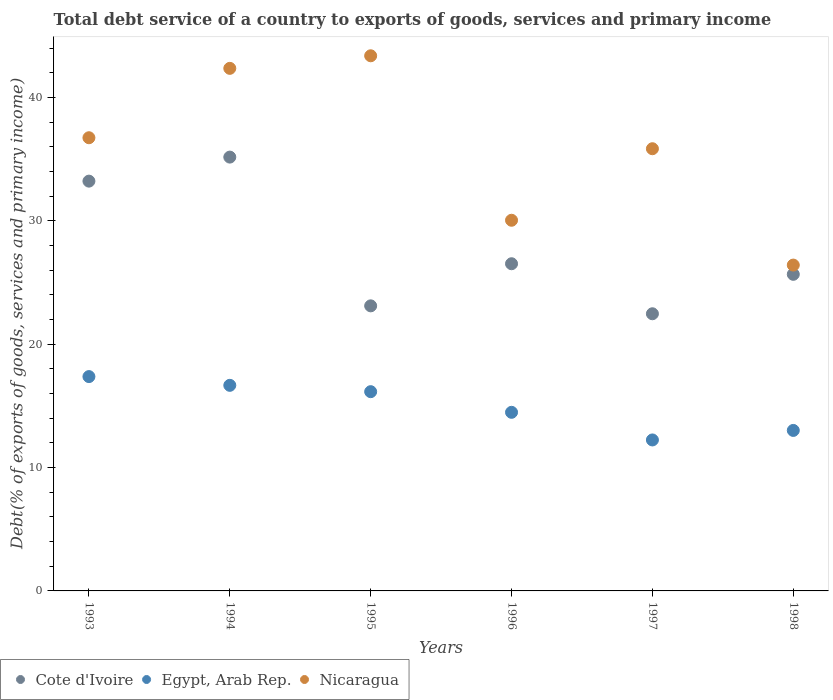How many different coloured dotlines are there?
Provide a succinct answer. 3. What is the total debt service in Nicaragua in 1997?
Your answer should be very brief. 35.85. Across all years, what is the maximum total debt service in Egypt, Arab Rep.?
Offer a very short reply. 17.38. Across all years, what is the minimum total debt service in Egypt, Arab Rep.?
Offer a terse response. 12.24. In which year was the total debt service in Nicaragua minimum?
Make the answer very short. 1998. What is the total total debt service in Nicaragua in the graph?
Make the answer very short. 214.82. What is the difference between the total debt service in Egypt, Arab Rep. in 1993 and that in 1998?
Give a very brief answer. 4.36. What is the difference between the total debt service in Nicaragua in 1998 and the total debt service in Egypt, Arab Rep. in 1996?
Ensure brevity in your answer.  11.94. What is the average total debt service in Cote d'Ivoire per year?
Keep it short and to the point. 27.7. In the year 1996, what is the difference between the total debt service in Cote d'Ivoire and total debt service in Nicaragua?
Offer a very short reply. -3.53. What is the ratio of the total debt service in Cote d'Ivoire in 1994 to that in 1996?
Offer a very short reply. 1.33. What is the difference between the highest and the second highest total debt service in Nicaragua?
Make the answer very short. 1.02. What is the difference between the highest and the lowest total debt service in Cote d'Ivoire?
Give a very brief answer. 12.7. Does the total debt service in Egypt, Arab Rep. monotonically increase over the years?
Your answer should be compact. No. Is the total debt service in Egypt, Arab Rep. strictly less than the total debt service in Cote d'Ivoire over the years?
Offer a very short reply. Yes. How many dotlines are there?
Your answer should be very brief. 3. How many years are there in the graph?
Provide a short and direct response. 6. Are the values on the major ticks of Y-axis written in scientific E-notation?
Your answer should be very brief. No. Where does the legend appear in the graph?
Offer a terse response. Bottom left. How are the legend labels stacked?
Ensure brevity in your answer.  Horizontal. What is the title of the graph?
Your answer should be very brief. Total debt service of a country to exports of goods, services and primary income. Does "Caribbean small states" appear as one of the legend labels in the graph?
Give a very brief answer. No. What is the label or title of the Y-axis?
Give a very brief answer. Debt(% of exports of goods, services and primary income). What is the Debt(% of exports of goods, services and primary income) of Cote d'Ivoire in 1993?
Offer a terse response. 33.22. What is the Debt(% of exports of goods, services and primary income) in Egypt, Arab Rep. in 1993?
Ensure brevity in your answer.  17.38. What is the Debt(% of exports of goods, services and primary income) in Nicaragua in 1993?
Offer a terse response. 36.74. What is the Debt(% of exports of goods, services and primary income) of Cote d'Ivoire in 1994?
Offer a very short reply. 35.17. What is the Debt(% of exports of goods, services and primary income) of Egypt, Arab Rep. in 1994?
Give a very brief answer. 16.67. What is the Debt(% of exports of goods, services and primary income) of Nicaragua in 1994?
Your answer should be very brief. 42.37. What is the Debt(% of exports of goods, services and primary income) in Cote d'Ivoire in 1995?
Your answer should be compact. 23.11. What is the Debt(% of exports of goods, services and primary income) of Egypt, Arab Rep. in 1995?
Give a very brief answer. 16.15. What is the Debt(% of exports of goods, services and primary income) of Nicaragua in 1995?
Offer a very short reply. 43.39. What is the Debt(% of exports of goods, services and primary income) in Cote d'Ivoire in 1996?
Offer a terse response. 26.53. What is the Debt(% of exports of goods, services and primary income) in Egypt, Arab Rep. in 1996?
Offer a very short reply. 14.48. What is the Debt(% of exports of goods, services and primary income) of Nicaragua in 1996?
Ensure brevity in your answer.  30.05. What is the Debt(% of exports of goods, services and primary income) of Cote d'Ivoire in 1997?
Keep it short and to the point. 22.47. What is the Debt(% of exports of goods, services and primary income) in Egypt, Arab Rep. in 1997?
Make the answer very short. 12.24. What is the Debt(% of exports of goods, services and primary income) of Nicaragua in 1997?
Provide a short and direct response. 35.85. What is the Debt(% of exports of goods, services and primary income) of Cote d'Ivoire in 1998?
Ensure brevity in your answer.  25.67. What is the Debt(% of exports of goods, services and primary income) in Egypt, Arab Rep. in 1998?
Keep it short and to the point. 13.01. What is the Debt(% of exports of goods, services and primary income) of Nicaragua in 1998?
Offer a terse response. 26.42. Across all years, what is the maximum Debt(% of exports of goods, services and primary income) of Cote d'Ivoire?
Provide a short and direct response. 35.17. Across all years, what is the maximum Debt(% of exports of goods, services and primary income) in Egypt, Arab Rep.?
Your response must be concise. 17.38. Across all years, what is the maximum Debt(% of exports of goods, services and primary income) in Nicaragua?
Your answer should be very brief. 43.39. Across all years, what is the minimum Debt(% of exports of goods, services and primary income) of Cote d'Ivoire?
Provide a short and direct response. 22.47. Across all years, what is the minimum Debt(% of exports of goods, services and primary income) in Egypt, Arab Rep.?
Keep it short and to the point. 12.24. Across all years, what is the minimum Debt(% of exports of goods, services and primary income) in Nicaragua?
Offer a very short reply. 26.42. What is the total Debt(% of exports of goods, services and primary income) of Cote d'Ivoire in the graph?
Keep it short and to the point. 166.17. What is the total Debt(% of exports of goods, services and primary income) of Egypt, Arab Rep. in the graph?
Offer a terse response. 89.93. What is the total Debt(% of exports of goods, services and primary income) in Nicaragua in the graph?
Offer a very short reply. 214.82. What is the difference between the Debt(% of exports of goods, services and primary income) of Cote d'Ivoire in 1993 and that in 1994?
Offer a very short reply. -1.95. What is the difference between the Debt(% of exports of goods, services and primary income) of Egypt, Arab Rep. in 1993 and that in 1994?
Give a very brief answer. 0.71. What is the difference between the Debt(% of exports of goods, services and primary income) of Nicaragua in 1993 and that in 1994?
Your answer should be compact. -5.62. What is the difference between the Debt(% of exports of goods, services and primary income) in Cote d'Ivoire in 1993 and that in 1995?
Offer a terse response. 10.11. What is the difference between the Debt(% of exports of goods, services and primary income) of Egypt, Arab Rep. in 1993 and that in 1995?
Offer a very short reply. 1.22. What is the difference between the Debt(% of exports of goods, services and primary income) of Nicaragua in 1993 and that in 1995?
Offer a terse response. -6.64. What is the difference between the Debt(% of exports of goods, services and primary income) in Cote d'Ivoire in 1993 and that in 1996?
Make the answer very short. 6.7. What is the difference between the Debt(% of exports of goods, services and primary income) in Egypt, Arab Rep. in 1993 and that in 1996?
Offer a very short reply. 2.9. What is the difference between the Debt(% of exports of goods, services and primary income) in Nicaragua in 1993 and that in 1996?
Keep it short and to the point. 6.69. What is the difference between the Debt(% of exports of goods, services and primary income) of Cote d'Ivoire in 1993 and that in 1997?
Provide a succinct answer. 10.75. What is the difference between the Debt(% of exports of goods, services and primary income) in Egypt, Arab Rep. in 1993 and that in 1997?
Provide a succinct answer. 5.14. What is the difference between the Debt(% of exports of goods, services and primary income) in Nicaragua in 1993 and that in 1997?
Your answer should be very brief. 0.89. What is the difference between the Debt(% of exports of goods, services and primary income) in Cote d'Ivoire in 1993 and that in 1998?
Provide a short and direct response. 7.56. What is the difference between the Debt(% of exports of goods, services and primary income) in Egypt, Arab Rep. in 1993 and that in 1998?
Provide a short and direct response. 4.36. What is the difference between the Debt(% of exports of goods, services and primary income) of Nicaragua in 1993 and that in 1998?
Your answer should be compact. 10.32. What is the difference between the Debt(% of exports of goods, services and primary income) of Cote d'Ivoire in 1994 and that in 1995?
Give a very brief answer. 12.06. What is the difference between the Debt(% of exports of goods, services and primary income) in Egypt, Arab Rep. in 1994 and that in 1995?
Provide a succinct answer. 0.51. What is the difference between the Debt(% of exports of goods, services and primary income) in Nicaragua in 1994 and that in 1995?
Provide a short and direct response. -1.02. What is the difference between the Debt(% of exports of goods, services and primary income) of Cote d'Ivoire in 1994 and that in 1996?
Provide a short and direct response. 8.65. What is the difference between the Debt(% of exports of goods, services and primary income) of Egypt, Arab Rep. in 1994 and that in 1996?
Your answer should be compact. 2.19. What is the difference between the Debt(% of exports of goods, services and primary income) of Nicaragua in 1994 and that in 1996?
Give a very brief answer. 12.32. What is the difference between the Debt(% of exports of goods, services and primary income) in Cote d'Ivoire in 1994 and that in 1997?
Give a very brief answer. 12.7. What is the difference between the Debt(% of exports of goods, services and primary income) in Egypt, Arab Rep. in 1994 and that in 1997?
Provide a succinct answer. 4.43. What is the difference between the Debt(% of exports of goods, services and primary income) in Nicaragua in 1994 and that in 1997?
Your answer should be very brief. 6.52. What is the difference between the Debt(% of exports of goods, services and primary income) of Cote d'Ivoire in 1994 and that in 1998?
Your answer should be very brief. 9.5. What is the difference between the Debt(% of exports of goods, services and primary income) of Egypt, Arab Rep. in 1994 and that in 1998?
Keep it short and to the point. 3.66. What is the difference between the Debt(% of exports of goods, services and primary income) in Nicaragua in 1994 and that in 1998?
Your response must be concise. 15.95. What is the difference between the Debt(% of exports of goods, services and primary income) of Cote d'Ivoire in 1995 and that in 1996?
Your response must be concise. -3.41. What is the difference between the Debt(% of exports of goods, services and primary income) in Egypt, Arab Rep. in 1995 and that in 1996?
Provide a short and direct response. 1.67. What is the difference between the Debt(% of exports of goods, services and primary income) of Nicaragua in 1995 and that in 1996?
Your response must be concise. 13.33. What is the difference between the Debt(% of exports of goods, services and primary income) of Cote d'Ivoire in 1995 and that in 1997?
Your answer should be compact. 0.64. What is the difference between the Debt(% of exports of goods, services and primary income) in Egypt, Arab Rep. in 1995 and that in 1997?
Offer a terse response. 3.91. What is the difference between the Debt(% of exports of goods, services and primary income) of Nicaragua in 1995 and that in 1997?
Offer a very short reply. 7.54. What is the difference between the Debt(% of exports of goods, services and primary income) in Cote d'Ivoire in 1995 and that in 1998?
Make the answer very short. -2.56. What is the difference between the Debt(% of exports of goods, services and primary income) in Egypt, Arab Rep. in 1995 and that in 1998?
Ensure brevity in your answer.  3.14. What is the difference between the Debt(% of exports of goods, services and primary income) in Nicaragua in 1995 and that in 1998?
Your answer should be compact. 16.97. What is the difference between the Debt(% of exports of goods, services and primary income) of Cote d'Ivoire in 1996 and that in 1997?
Give a very brief answer. 4.06. What is the difference between the Debt(% of exports of goods, services and primary income) of Egypt, Arab Rep. in 1996 and that in 1997?
Keep it short and to the point. 2.24. What is the difference between the Debt(% of exports of goods, services and primary income) in Nicaragua in 1996 and that in 1997?
Provide a short and direct response. -5.8. What is the difference between the Debt(% of exports of goods, services and primary income) in Cote d'Ivoire in 1996 and that in 1998?
Provide a succinct answer. 0.86. What is the difference between the Debt(% of exports of goods, services and primary income) in Egypt, Arab Rep. in 1996 and that in 1998?
Ensure brevity in your answer.  1.47. What is the difference between the Debt(% of exports of goods, services and primary income) in Nicaragua in 1996 and that in 1998?
Keep it short and to the point. 3.63. What is the difference between the Debt(% of exports of goods, services and primary income) in Cote d'Ivoire in 1997 and that in 1998?
Ensure brevity in your answer.  -3.2. What is the difference between the Debt(% of exports of goods, services and primary income) in Egypt, Arab Rep. in 1997 and that in 1998?
Offer a terse response. -0.77. What is the difference between the Debt(% of exports of goods, services and primary income) in Nicaragua in 1997 and that in 1998?
Give a very brief answer. 9.43. What is the difference between the Debt(% of exports of goods, services and primary income) in Cote d'Ivoire in 1993 and the Debt(% of exports of goods, services and primary income) in Egypt, Arab Rep. in 1994?
Ensure brevity in your answer.  16.55. What is the difference between the Debt(% of exports of goods, services and primary income) of Cote d'Ivoire in 1993 and the Debt(% of exports of goods, services and primary income) of Nicaragua in 1994?
Provide a succinct answer. -9.14. What is the difference between the Debt(% of exports of goods, services and primary income) in Egypt, Arab Rep. in 1993 and the Debt(% of exports of goods, services and primary income) in Nicaragua in 1994?
Give a very brief answer. -24.99. What is the difference between the Debt(% of exports of goods, services and primary income) of Cote d'Ivoire in 1993 and the Debt(% of exports of goods, services and primary income) of Egypt, Arab Rep. in 1995?
Your response must be concise. 17.07. What is the difference between the Debt(% of exports of goods, services and primary income) of Cote d'Ivoire in 1993 and the Debt(% of exports of goods, services and primary income) of Nicaragua in 1995?
Provide a succinct answer. -10.16. What is the difference between the Debt(% of exports of goods, services and primary income) of Egypt, Arab Rep. in 1993 and the Debt(% of exports of goods, services and primary income) of Nicaragua in 1995?
Offer a terse response. -26.01. What is the difference between the Debt(% of exports of goods, services and primary income) in Cote d'Ivoire in 1993 and the Debt(% of exports of goods, services and primary income) in Egypt, Arab Rep. in 1996?
Offer a terse response. 18.74. What is the difference between the Debt(% of exports of goods, services and primary income) in Cote d'Ivoire in 1993 and the Debt(% of exports of goods, services and primary income) in Nicaragua in 1996?
Provide a short and direct response. 3.17. What is the difference between the Debt(% of exports of goods, services and primary income) in Egypt, Arab Rep. in 1993 and the Debt(% of exports of goods, services and primary income) in Nicaragua in 1996?
Your answer should be very brief. -12.68. What is the difference between the Debt(% of exports of goods, services and primary income) of Cote d'Ivoire in 1993 and the Debt(% of exports of goods, services and primary income) of Egypt, Arab Rep. in 1997?
Offer a very short reply. 20.98. What is the difference between the Debt(% of exports of goods, services and primary income) in Cote d'Ivoire in 1993 and the Debt(% of exports of goods, services and primary income) in Nicaragua in 1997?
Make the answer very short. -2.63. What is the difference between the Debt(% of exports of goods, services and primary income) in Egypt, Arab Rep. in 1993 and the Debt(% of exports of goods, services and primary income) in Nicaragua in 1997?
Ensure brevity in your answer.  -18.47. What is the difference between the Debt(% of exports of goods, services and primary income) in Cote d'Ivoire in 1993 and the Debt(% of exports of goods, services and primary income) in Egypt, Arab Rep. in 1998?
Ensure brevity in your answer.  20.21. What is the difference between the Debt(% of exports of goods, services and primary income) of Cote d'Ivoire in 1993 and the Debt(% of exports of goods, services and primary income) of Nicaragua in 1998?
Your answer should be very brief. 6.81. What is the difference between the Debt(% of exports of goods, services and primary income) in Egypt, Arab Rep. in 1993 and the Debt(% of exports of goods, services and primary income) in Nicaragua in 1998?
Keep it short and to the point. -9.04. What is the difference between the Debt(% of exports of goods, services and primary income) in Cote d'Ivoire in 1994 and the Debt(% of exports of goods, services and primary income) in Egypt, Arab Rep. in 1995?
Provide a short and direct response. 19.02. What is the difference between the Debt(% of exports of goods, services and primary income) of Cote d'Ivoire in 1994 and the Debt(% of exports of goods, services and primary income) of Nicaragua in 1995?
Ensure brevity in your answer.  -8.21. What is the difference between the Debt(% of exports of goods, services and primary income) in Egypt, Arab Rep. in 1994 and the Debt(% of exports of goods, services and primary income) in Nicaragua in 1995?
Make the answer very short. -26.72. What is the difference between the Debt(% of exports of goods, services and primary income) of Cote d'Ivoire in 1994 and the Debt(% of exports of goods, services and primary income) of Egypt, Arab Rep. in 1996?
Offer a very short reply. 20.69. What is the difference between the Debt(% of exports of goods, services and primary income) in Cote d'Ivoire in 1994 and the Debt(% of exports of goods, services and primary income) in Nicaragua in 1996?
Keep it short and to the point. 5.12. What is the difference between the Debt(% of exports of goods, services and primary income) of Egypt, Arab Rep. in 1994 and the Debt(% of exports of goods, services and primary income) of Nicaragua in 1996?
Ensure brevity in your answer.  -13.38. What is the difference between the Debt(% of exports of goods, services and primary income) in Cote d'Ivoire in 1994 and the Debt(% of exports of goods, services and primary income) in Egypt, Arab Rep. in 1997?
Make the answer very short. 22.93. What is the difference between the Debt(% of exports of goods, services and primary income) of Cote d'Ivoire in 1994 and the Debt(% of exports of goods, services and primary income) of Nicaragua in 1997?
Keep it short and to the point. -0.68. What is the difference between the Debt(% of exports of goods, services and primary income) in Egypt, Arab Rep. in 1994 and the Debt(% of exports of goods, services and primary income) in Nicaragua in 1997?
Offer a terse response. -19.18. What is the difference between the Debt(% of exports of goods, services and primary income) in Cote d'Ivoire in 1994 and the Debt(% of exports of goods, services and primary income) in Egypt, Arab Rep. in 1998?
Your response must be concise. 22.16. What is the difference between the Debt(% of exports of goods, services and primary income) of Cote d'Ivoire in 1994 and the Debt(% of exports of goods, services and primary income) of Nicaragua in 1998?
Make the answer very short. 8.75. What is the difference between the Debt(% of exports of goods, services and primary income) in Egypt, Arab Rep. in 1994 and the Debt(% of exports of goods, services and primary income) in Nicaragua in 1998?
Your answer should be compact. -9.75. What is the difference between the Debt(% of exports of goods, services and primary income) of Cote d'Ivoire in 1995 and the Debt(% of exports of goods, services and primary income) of Egypt, Arab Rep. in 1996?
Provide a short and direct response. 8.63. What is the difference between the Debt(% of exports of goods, services and primary income) in Cote d'Ivoire in 1995 and the Debt(% of exports of goods, services and primary income) in Nicaragua in 1996?
Your answer should be very brief. -6.94. What is the difference between the Debt(% of exports of goods, services and primary income) of Egypt, Arab Rep. in 1995 and the Debt(% of exports of goods, services and primary income) of Nicaragua in 1996?
Offer a terse response. -13.9. What is the difference between the Debt(% of exports of goods, services and primary income) in Cote d'Ivoire in 1995 and the Debt(% of exports of goods, services and primary income) in Egypt, Arab Rep. in 1997?
Ensure brevity in your answer.  10.87. What is the difference between the Debt(% of exports of goods, services and primary income) of Cote d'Ivoire in 1995 and the Debt(% of exports of goods, services and primary income) of Nicaragua in 1997?
Give a very brief answer. -12.74. What is the difference between the Debt(% of exports of goods, services and primary income) in Egypt, Arab Rep. in 1995 and the Debt(% of exports of goods, services and primary income) in Nicaragua in 1997?
Your response must be concise. -19.7. What is the difference between the Debt(% of exports of goods, services and primary income) in Cote d'Ivoire in 1995 and the Debt(% of exports of goods, services and primary income) in Egypt, Arab Rep. in 1998?
Provide a succinct answer. 10.1. What is the difference between the Debt(% of exports of goods, services and primary income) of Cote d'Ivoire in 1995 and the Debt(% of exports of goods, services and primary income) of Nicaragua in 1998?
Offer a very short reply. -3.31. What is the difference between the Debt(% of exports of goods, services and primary income) in Egypt, Arab Rep. in 1995 and the Debt(% of exports of goods, services and primary income) in Nicaragua in 1998?
Provide a succinct answer. -10.26. What is the difference between the Debt(% of exports of goods, services and primary income) of Cote d'Ivoire in 1996 and the Debt(% of exports of goods, services and primary income) of Egypt, Arab Rep. in 1997?
Keep it short and to the point. 14.29. What is the difference between the Debt(% of exports of goods, services and primary income) of Cote d'Ivoire in 1996 and the Debt(% of exports of goods, services and primary income) of Nicaragua in 1997?
Keep it short and to the point. -9.32. What is the difference between the Debt(% of exports of goods, services and primary income) in Egypt, Arab Rep. in 1996 and the Debt(% of exports of goods, services and primary income) in Nicaragua in 1997?
Offer a terse response. -21.37. What is the difference between the Debt(% of exports of goods, services and primary income) of Cote d'Ivoire in 1996 and the Debt(% of exports of goods, services and primary income) of Egypt, Arab Rep. in 1998?
Your response must be concise. 13.51. What is the difference between the Debt(% of exports of goods, services and primary income) in Cote d'Ivoire in 1996 and the Debt(% of exports of goods, services and primary income) in Nicaragua in 1998?
Provide a succinct answer. 0.11. What is the difference between the Debt(% of exports of goods, services and primary income) in Egypt, Arab Rep. in 1996 and the Debt(% of exports of goods, services and primary income) in Nicaragua in 1998?
Offer a very short reply. -11.94. What is the difference between the Debt(% of exports of goods, services and primary income) of Cote d'Ivoire in 1997 and the Debt(% of exports of goods, services and primary income) of Egypt, Arab Rep. in 1998?
Ensure brevity in your answer.  9.46. What is the difference between the Debt(% of exports of goods, services and primary income) in Cote d'Ivoire in 1997 and the Debt(% of exports of goods, services and primary income) in Nicaragua in 1998?
Ensure brevity in your answer.  -3.95. What is the difference between the Debt(% of exports of goods, services and primary income) in Egypt, Arab Rep. in 1997 and the Debt(% of exports of goods, services and primary income) in Nicaragua in 1998?
Your answer should be compact. -14.18. What is the average Debt(% of exports of goods, services and primary income) of Cote d'Ivoire per year?
Provide a succinct answer. 27.7. What is the average Debt(% of exports of goods, services and primary income) of Egypt, Arab Rep. per year?
Your response must be concise. 14.99. What is the average Debt(% of exports of goods, services and primary income) in Nicaragua per year?
Ensure brevity in your answer.  35.8. In the year 1993, what is the difference between the Debt(% of exports of goods, services and primary income) in Cote d'Ivoire and Debt(% of exports of goods, services and primary income) in Egypt, Arab Rep.?
Give a very brief answer. 15.85. In the year 1993, what is the difference between the Debt(% of exports of goods, services and primary income) of Cote d'Ivoire and Debt(% of exports of goods, services and primary income) of Nicaragua?
Make the answer very short. -3.52. In the year 1993, what is the difference between the Debt(% of exports of goods, services and primary income) in Egypt, Arab Rep. and Debt(% of exports of goods, services and primary income) in Nicaragua?
Give a very brief answer. -19.37. In the year 1994, what is the difference between the Debt(% of exports of goods, services and primary income) in Cote d'Ivoire and Debt(% of exports of goods, services and primary income) in Egypt, Arab Rep.?
Your response must be concise. 18.5. In the year 1994, what is the difference between the Debt(% of exports of goods, services and primary income) of Cote d'Ivoire and Debt(% of exports of goods, services and primary income) of Nicaragua?
Your answer should be compact. -7.2. In the year 1994, what is the difference between the Debt(% of exports of goods, services and primary income) of Egypt, Arab Rep. and Debt(% of exports of goods, services and primary income) of Nicaragua?
Keep it short and to the point. -25.7. In the year 1995, what is the difference between the Debt(% of exports of goods, services and primary income) in Cote d'Ivoire and Debt(% of exports of goods, services and primary income) in Egypt, Arab Rep.?
Keep it short and to the point. 6.96. In the year 1995, what is the difference between the Debt(% of exports of goods, services and primary income) of Cote d'Ivoire and Debt(% of exports of goods, services and primary income) of Nicaragua?
Keep it short and to the point. -20.27. In the year 1995, what is the difference between the Debt(% of exports of goods, services and primary income) in Egypt, Arab Rep. and Debt(% of exports of goods, services and primary income) in Nicaragua?
Make the answer very short. -27.23. In the year 1996, what is the difference between the Debt(% of exports of goods, services and primary income) of Cote d'Ivoire and Debt(% of exports of goods, services and primary income) of Egypt, Arab Rep.?
Your answer should be very brief. 12.05. In the year 1996, what is the difference between the Debt(% of exports of goods, services and primary income) in Cote d'Ivoire and Debt(% of exports of goods, services and primary income) in Nicaragua?
Keep it short and to the point. -3.53. In the year 1996, what is the difference between the Debt(% of exports of goods, services and primary income) of Egypt, Arab Rep. and Debt(% of exports of goods, services and primary income) of Nicaragua?
Give a very brief answer. -15.57. In the year 1997, what is the difference between the Debt(% of exports of goods, services and primary income) of Cote d'Ivoire and Debt(% of exports of goods, services and primary income) of Egypt, Arab Rep.?
Your answer should be compact. 10.23. In the year 1997, what is the difference between the Debt(% of exports of goods, services and primary income) of Cote d'Ivoire and Debt(% of exports of goods, services and primary income) of Nicaragua?
Your response must be concise. -13.38. In the year 1997, what is the difference between the Debt(% of exports of goods, services and primary income) in Egypt, Arab Rep. and Debt(% of exports of goods, services and primary income) in Nicaragua?
Your response must be concise. -23.61. In the year 1998, what is the difference between the Debt(% of exports of goods, services and primary income) of Cote d'Ivoire and Debt(% of exports of goods, services and primary income) of Egypt, Arab Rep.?
Make the answer very short. 12.66. In the year 1998, what is the difference between the Debt(% of exports of goods, services and primary income) of Cote d'Ivoire and Debt(% of exports of goods, services and primary income) of Nicaragua?
Provide a short and direct response. -0.75. In the year 1998, what is the difference between the Debt(% of exports of goods, services and primary income) in Egypt, Arab Rep. and Debt(% of exports of goods, services and primary income) in Nicaragua?
Your answer should be compact. -13.41. What is the ratio of the Debt(% of exports of goods, services and primary income) of Cote d'Ivoire in 1993 to that in 1994?
Keep it short and to the point. 0.94. What is the ratio of the Debt(% of exports of goods, services and primary income) of Egypt, Arab Rep. in 1993 to that in 1994?
Offer a very short reply. 1.04. What is the ratio of the Debt(% of exports of goods, services and primary income) in Nicaragua in 1993 to that in 1994?
Offer a terse response. 0.87. What is the ratio of the Debt(% of exports of goods, services and primary income) in Cote d'Ivoire in 1993 to that in 1995?
Your answer should be compact. 1.44. What is the ratio of the Debt(% of exports of goods, services and primary income) in Egypt, Arab Rep. in 1993 to that in 1995?
Offer a very short reply. 1.08. What is the ratio of the Debt(% of exports of goods, services and primary income) in Nicaragua in 1993 to that in 1995?
Your answer should be compact. 0.85. What is the ratio of the Debt(% of exports of goods, services and primary income) in Cote d'Ivoire in 1993 to that in 1996?
Your response must be concise. 1.25. What is the ratio of the Debt(% of exports of goods, services and primary income) in Nicaragua in 1993 to that in 1996?
Offer a very short reply. 1.22. What is the ratio of the Debt(% of exports of goods, services and primary income) of Cote d'Ivoire in 1993 to that in 1997?
Keep it short and to the point. 1.48. What is the ratio of the Debt(% of exports of goods, services and primary income) in Egypt, Arab Rep. in 1993 to that in 1997?
Offer a terse response. 1.42. What is the ratio of the Debt(% of exports of goods, services and primary income) in Nicaragua in 1993 to that in 1997?
Ensure brevity in your answer.  1.02. What is the ratio of the Debt(% of exports of goods, services and primary income) in Cote d'Ivoire in 1993 to that in 1998?
Provide a short and direct response. 1.29. What is the ratio of the Debt(% of exports of goods, services and primary income) in Egypt, Arab Rep. in 1993 to that in 1998?
Your answer should be compact. 1.34. What is the ratio of the Debt(% of exports of goods, services and primary income) in Nicaragua in 1993 to that in 1998?
Give a very brief answer. 1.39. What is the ratio of the Debt(% of exports of goods, services and primary income) in Cote d'Ivoire in 1994 to that in 1995?
Your answer should be compact. 1.52. What is the ratio of the Debt(% of exports of goods, services and primary income) in Egypt, Arab Rep. in 1994 to that in 1995?
Give a very brief answer. 1.03. What is the ratio of the Debt(% of exports of goods, services and primary income) in Nicaragua in 1994 to that in 1995?
Your answer should be very brief. 0.98. What is the ratio of the Debt(% of exports of goods, services and primary income) in Cote d'Ivoire in 1994 to that in 1996?
Your response must be concise. 1.33. What is the ratio of the Debt(% of exports of goods, services and primary income) in Egypt, Arab Rep. in 1994 to that in 1996?
Your answer should be very brief. 1.15. What is the ratio of the Debt(% of exports of goods, services and primary income) of Nicaragua in 1994 to that in 1996?
Provide a short and direct response. 1.41. What is the ratio of the Debt(% of exports of goods, services and primary income) in Cote d'Ivoire in 1994 to that in 1997?
Offer a very short reply. 1.57. What is the ratio of the Debt(% of exports of goods, services and primary income) of Egypt, Arab Rep. in 1994 to that in 1997?
Make the answer very short. 1.36. What is the ratio of the Debt(% of exports of goods, services and primary income) in Nicaragua in 1994 to that in 1997?
Provide a short and direct response. 1.18. What is the ratio of the Debt(% of exports of goods, services and primary income) in Cote d'Ivoire in 1994 to that in 1998?
Offer a very short reply. 1.37. What is the ratio of the Debt(% of exports of goods, services and primary income) in Egypt, Arab Rep. in 1994 to that in 1998?
Ensure brevity in your answer.  1.28. What is the ratio of the Debt(% of exports of goods, services and primary income) of Nicaragua in 1994 to that in 1998?
Provide a short and direct response. 1.6. What is the ratio of the Debt(% of exports of goods, services and primary income) of Cote d'Ivoire in 1995 to that in 1996?
Your answer should be compact. 0.87. What is the ratio of the Debt(% of exports of goods, services and primary income) of Egypt, Arab Rep. in 1995 to that in 1996?
Give a very brief answer. 1.12. What is the ratio of the Debt(% of exports of goods, services and primary income) of Nicaragua in 1995 to that in 1996?
Your answer should be very brief. 1.44. What is the ratio of the Debt(% of exports of goods, services and primary income) of Cote d'Ivoire in 1995 to that in 1997?
Offer a terse response. 1.03. What is the ratio of the Debt(% of exports of goods, services and primary income) in Egypt, Arab Rep. in 1995 to that in 1997?
Keep it short and to the point. 1.32. What is the ratio of the Debt(% of exports of goods, services and primary income) in Nicaragua in 1995 to that in 1997?
Keep it short and to the point. 1.21. What is the ratio of the Debt(% of exports of goods, services and primary income) of Cote d'Ivoire in 1995 to that in 1998?
Provide a short and direct response. 0.9. What is the ratio of the Debt(% of exports of goods, services and primary income) of Egypt, Arab Rep. in 1995 to that in 1998?
Ensure brevity in your answer.  1.24. What is the ratio of the Debt(% of exports of goods, services and primary income) of Nicaragua in 1995 to that in 1998?
Provide a short and direct response. 1.64. What is the ratio of the Debt(% of exports of goods, services and primary income) of Cote d'Ivoire in 1996 to that in 1997?
Ensure brevity in your answer.  1.18. What is the ratio of the Debt(% of exports of goods, services and primary income) of Egypt, Arab Rep. in 1996 to that in 1997?
Make the answer very short. 1.18. What is the ratio of the Debt(% of exports of goods, services and primary income) of Nicaragua in 1996 to that in 1997?
Your answer should be compact. 0.84. What is the ratio of the Debt(% of exports of goods, services and primary income) in Cote d'Ivoire in 1996 to that in 1998?
Your answer should be compact. 1.03. What is the ratio of the Debt(% of exports of goods, services and primary income) in Egypt, Arab Rep. in 1996 to that in 1998?
Make the answer very short. 1.11. What is the ratio of the Debt(% of exports of goods, services and primary income) in Nicaragua in 1996 to that in 1998?
Ensure brevity in your answer.  1.14. What is the ratio of the Debt(% of exports of goods, services and primary income) of Cote d'Ivoire in 1997 to that in 1998?
Give a very brief answer. 0.88. What is the ratio of the Debt(% of exports of goods, services and primary income) of Egypt, Arab Rep. in 1997 to that in 1998?
Your response must be concise. 0.94. What is the ratio of the Debt(% of exports of goods, services and primary income) in Nicaragua in 1997 to that in 1998?
Your response must be concise. 1.36. What is the difference between the highest and the second highest Debt(% of exports of goods, services and primary income) in Cote d'Ivoire?
Provide a succinct answer. 1.95. What is the difference between the highest and the second highest Debt(% of exports of goods, services and primary income) in Egypt, Arab Rep.?
Keep it short and to the point. 0.71. What is the difference between the highest and the second highest Debt(% of exports of goods, services and primary income) of Nicaragua?
Provide a succinct answer. 1.02. What is the difference between the highest and the lowest Debt(% of exports of goods, services and primary income) in Cote d'Ivoire?
Keep it short and to the point. 12.7. What is the difference between the highest and the lowest Debt(% of exports of goods, services and primary income) of Egypt, Arab Rep.?
Your response must be concise. 5.14. What is the difference between the highest and the lowest Debt(% of exports of goods, services and primary income) of Nicaragua?
Keep it short and to the point. 16.97. 